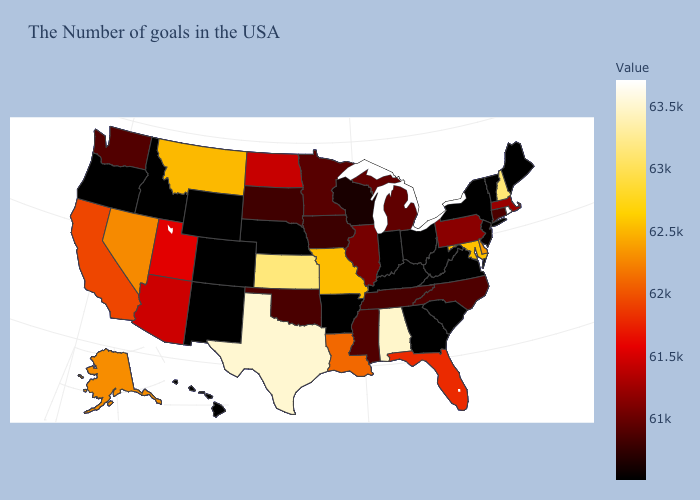Which states hav the highest value in the South?
Write a very short answer. Texas. Among the states that border Utah , does Arizona have the lowest value?
Write a very short answer. No. Which states hav the highest value in the MidWest?
Keep it brief. Kansas. Among the states that border New York , which have the lowest value?
Answer briefly. Vermont. Does Rhode Island have the highest value in the USA?
Quick response, please. Yes. Does the map have missing data?
Concise answer only. No. Does Virginia have a lower value than North Carolina?
Quick response, please. Yes. Does Louisiana have the highest value in the USA?
Be succinct. No. Does Montana have the highest value in the USA?
Answer briefly. No. Does Missouri have a higher value than Washington?
Give a very brief answer. Yes. Does Maine have the highest value in the Northeast?
Short answer required. No. 